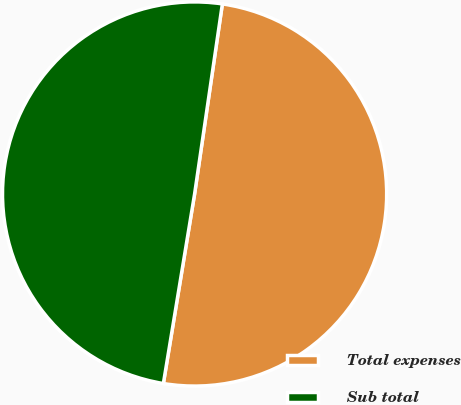Convert chart to OTSL. <chart><loc_0><loc_0><loc_500><loc_500><pie_chart><fcel>Total expenses<fcel>Sub total<nl><fcel>50.29%<fcel>49.71%<nl></chart> 